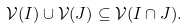Convert formula to latex. <formula><loc_0><loc_0><loc_500><loc_500>\mathcal { V } ( I ) \cup \mathcal { V } ( J ) \subseteq \mathcal { V } ( I \cap J ) .</formula> 